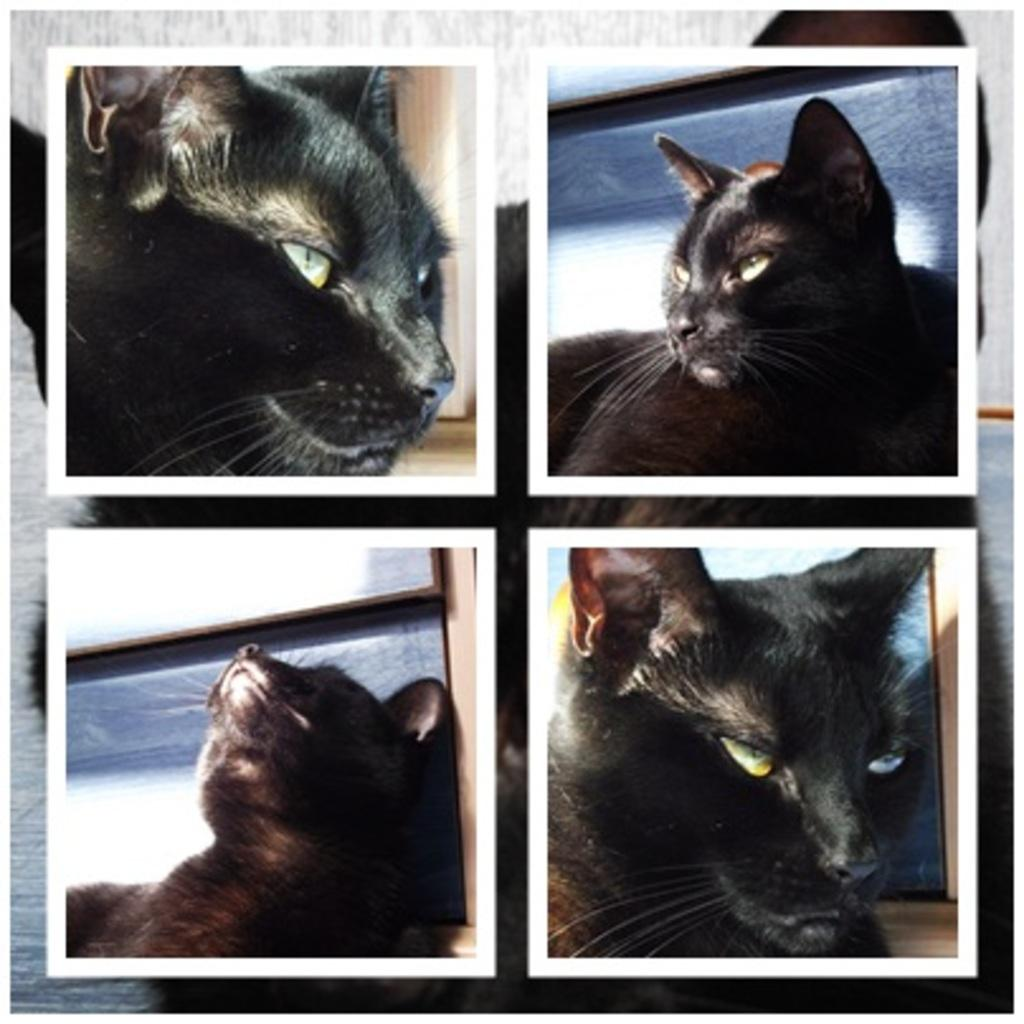What type of artwork is depicted in the image? The image is a collage. What type of animal can be seen in the collage? There are images of a cat in the collage. What type of plantation is visible in the image? There is no plantation present in the image; it is a collage featuring images of a cat. How many toes can be seen on the cat in the image? The image is a collage, and it is not possible to determine the number of toes on the cat from the provided information. 